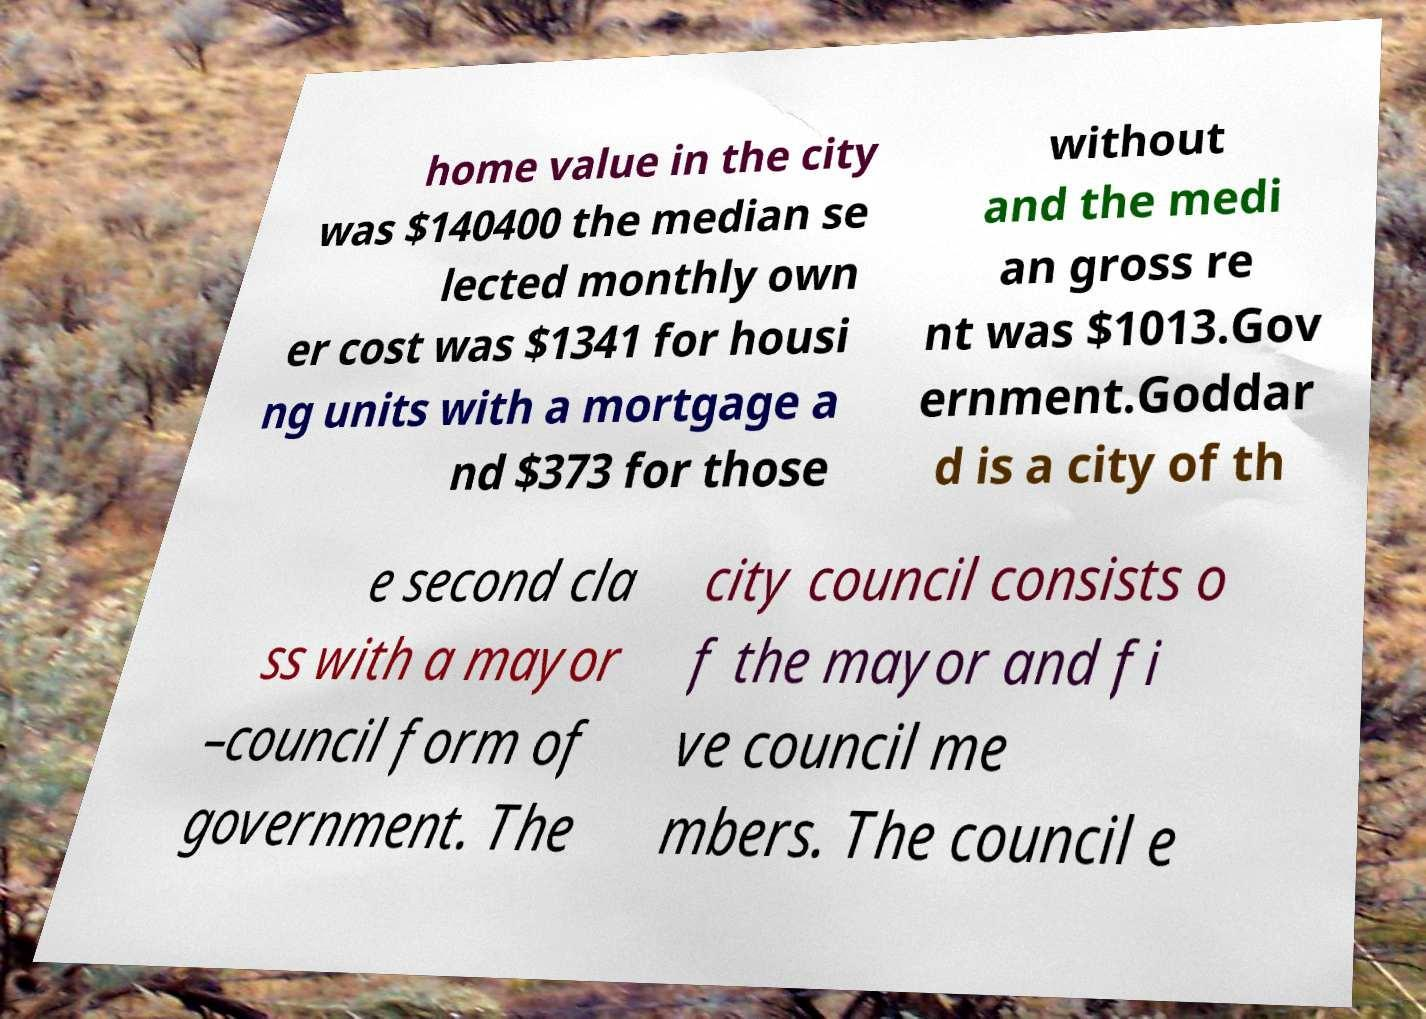What messages or text are displayed in this image? I need them in a readable, typed format. home value in the city was $140400 the median se lected monthly own er cost was $1341 for housi ng units with a mortgage a nd $373 for those without and the medi an gross re nt was $1013.Gov ernment.Goddar d is a city of th e second cla ss with a mayor –council form of government. The city council consists o f the mayor and fi ve council me mbers. The council e 